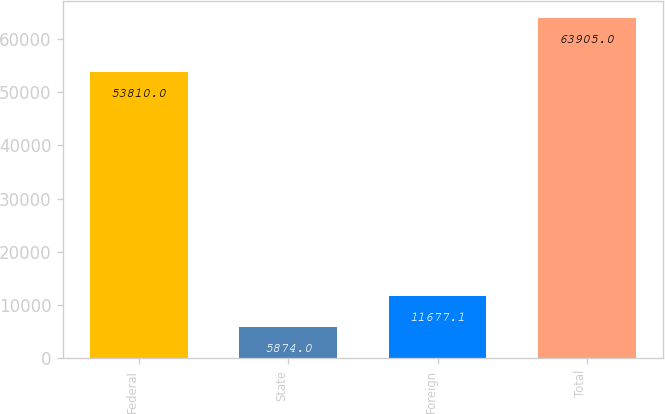<chart> <loc_0><loc_0><loc_500><loc_500><bar_chart><fcel>Federal<fcel>State<fcel>Foreign<fcel>Total<nl><fcel>53810<fcel>5874<fcel>11677.1<fcel>63905<nl></chart> 